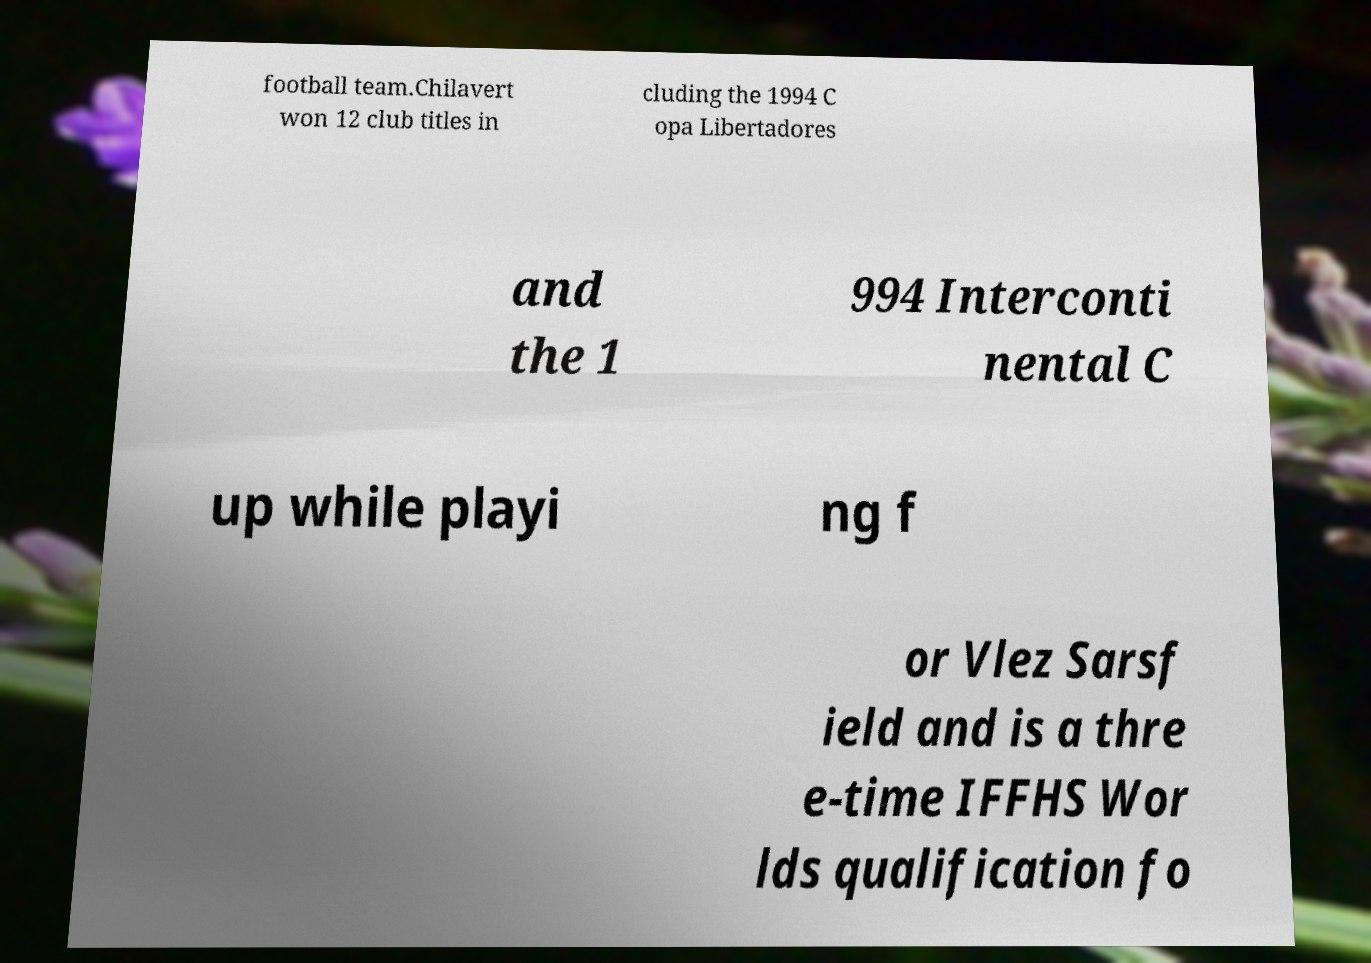Please read and relay the text visible in this image. What does it say? football team.Chilavert won 12 club titles in cluding the 1994 C opa Libertadores and the 1 994 Interconti nental C up while playi ng f or Vlez Sarsf ield and is a thre e-time IFFHS Wor lds qualification fo 